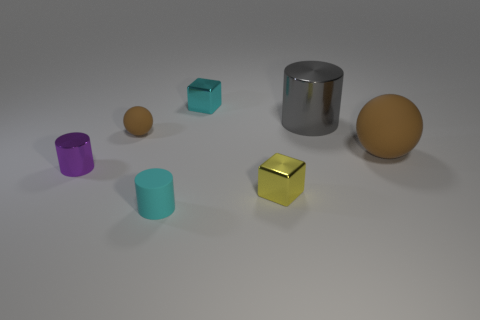What could be the context or setting for these objects? These objects could be part of a visual composition designed to study shapes, colors, and textures in 3D modeling or graphic design. The setting suggests a controlled environment, like a designer's workspace or an educational setup for teaching properties of 3D objects such as geometry, light interactions, and material properties. 